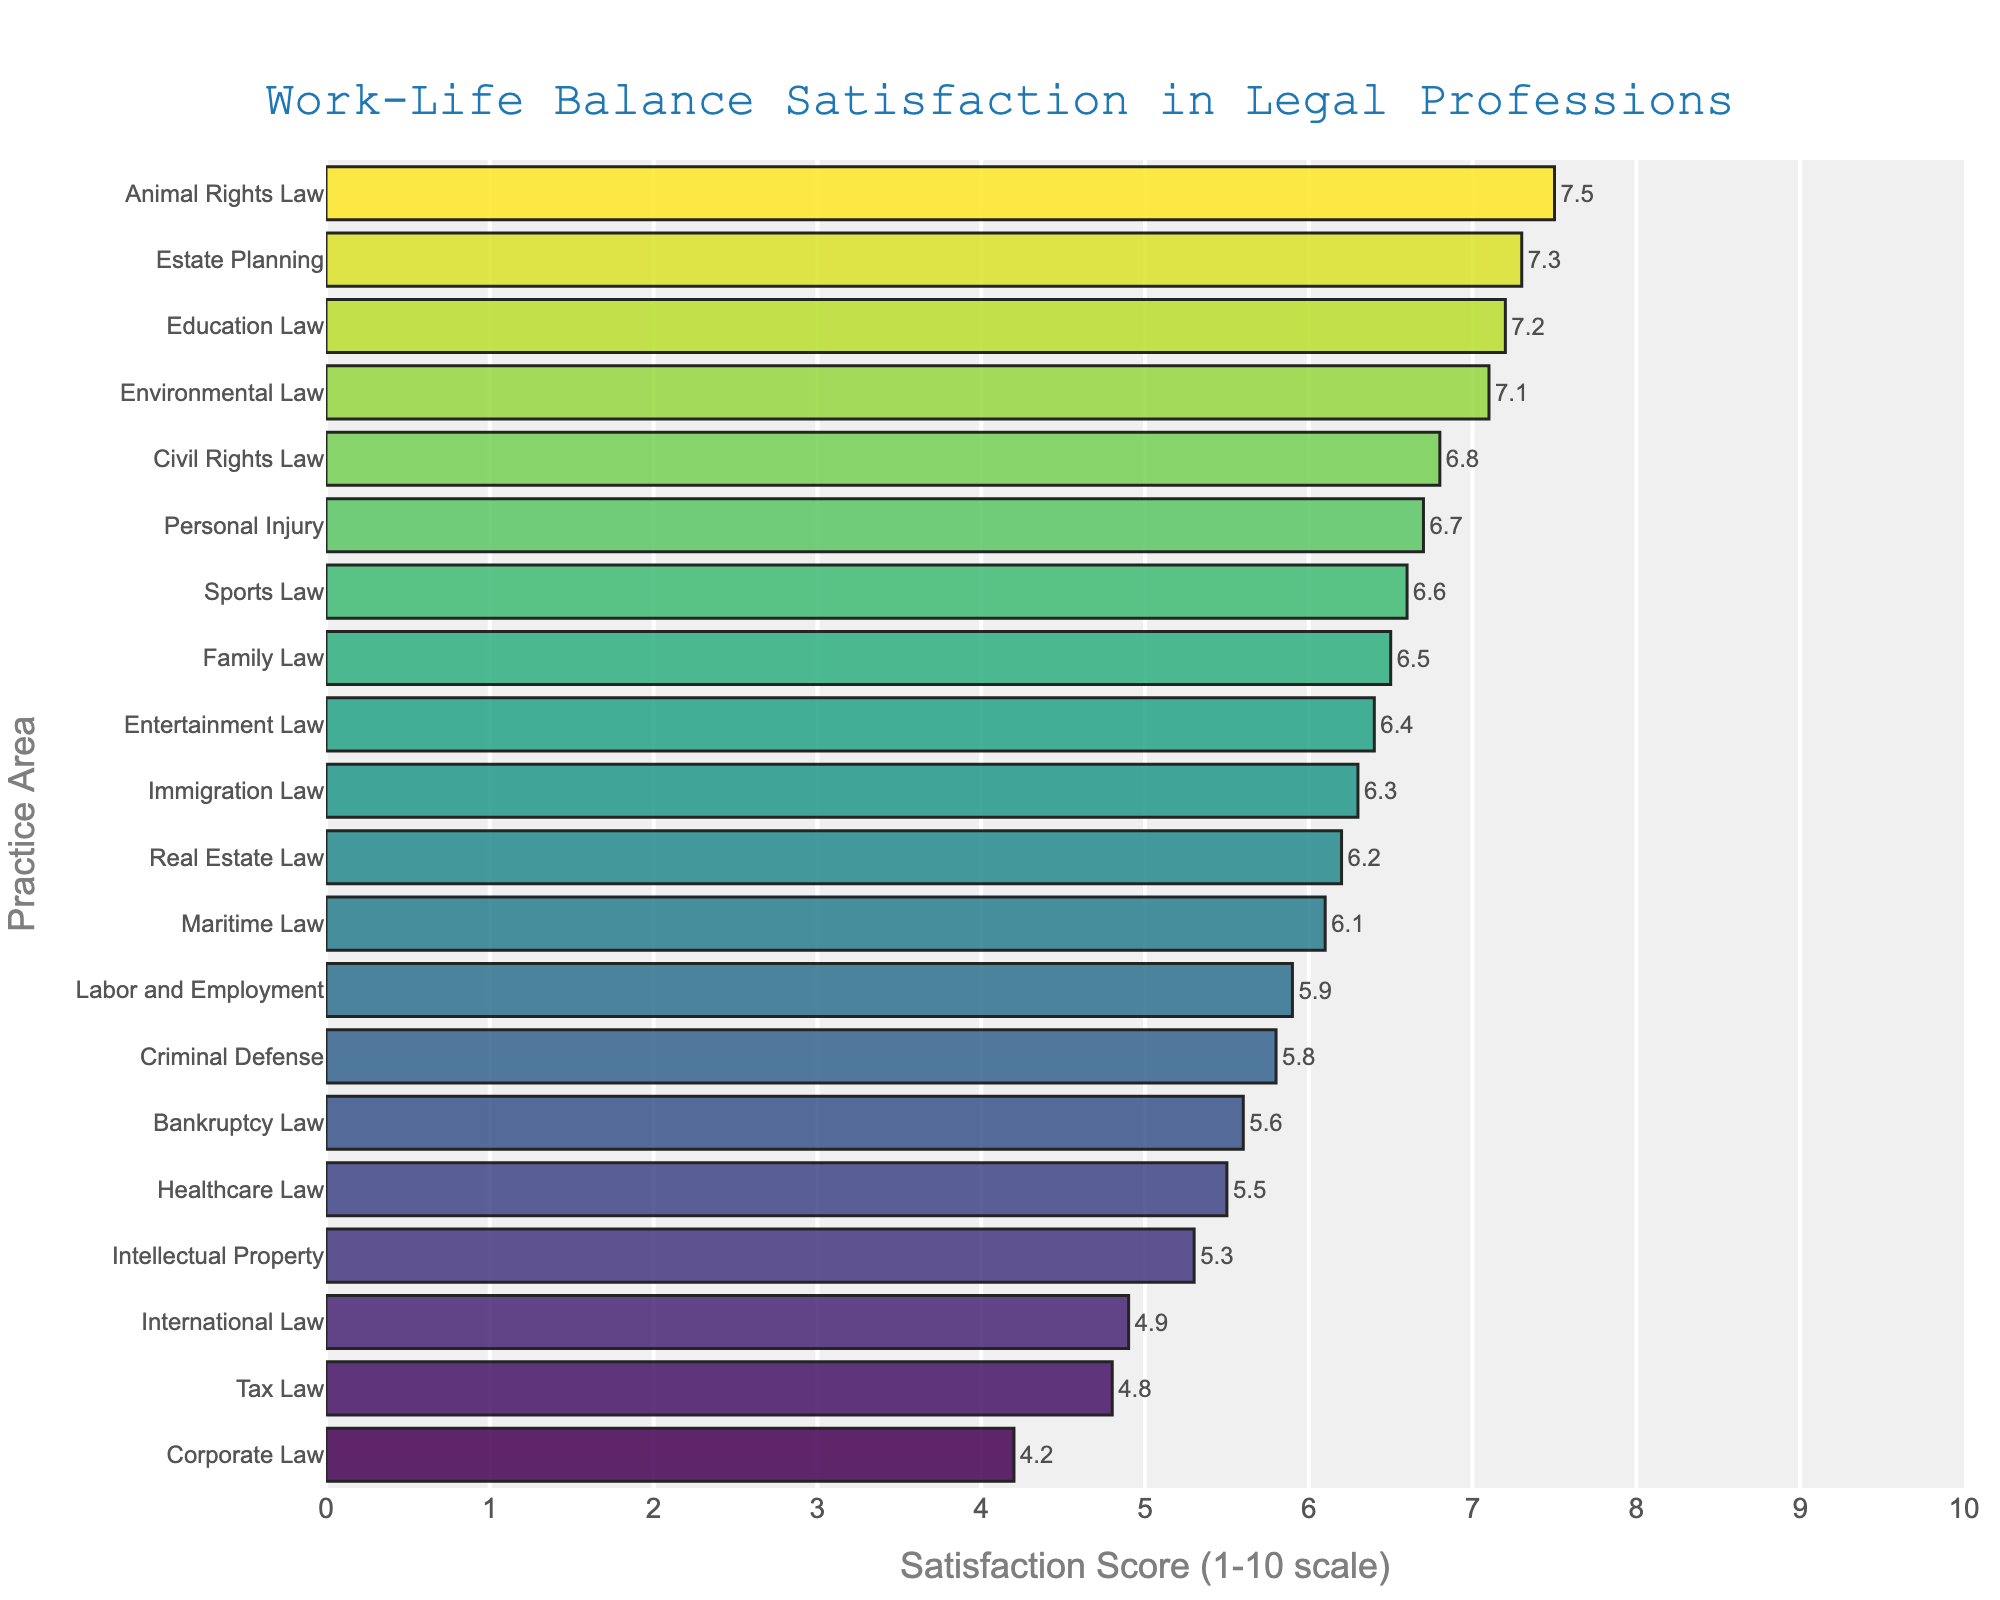How many practice areas have a satisfaction score above 6.0? First, identify the practice areas with scores above 6.0. These are Family Law (6.5), Real Estate Law (6.2), Personal Injury (6.7), Civil Rights Law (6.8), Entertainment Law (6.4), Immigration Law (6.3), Maritime Law (6.1), Sports Law (6.6), Education Law (7.2), Estate Planning (7.3), and Animal Rights Law (7.5). Count them: 11 practice areas have satisfaction scores above 6.0.
Answer: 11 Which practice area has the lowest work-life balance satisfaction score? Look at the leftmost bar in the chart, which represents the lowest score. The practice area corresponding to this bar is Corporate Law with a score of 4.2.
Answer: Corporate Law Is Intellectual Property’s satisfaction score higher or lower than Tax Law’s score? Examine the bars corresponding to Intellectual Property and Tax Law. Intellectual Property has a score of 5.3 and Tax Law has a score of 4.8. Compare these values: 5.3 is higher than 4.8.
Answer: Higher What is the difference in satisfaction score between the highest and lowest practice areas? Find the highest satisfaction score (Animal Rights Law with 7.5) and the lowest satisfaction score (Corporate Law with 4.2). Calculate the difference: 7.5 - 4.2 = 3.3.
Answer: 3.3 Which practice areas have a satisfaction score close to the average satisfaction score of all practice areas? First, calculate the average satisfaction score: (4.2 + 6.5 + 5.8 + 5.3 + 7.1 + 4.8 + 6.2 + 5.9 + 6.7 + 6.3 + 5.6 + 6.8 + 5.5 + 6.4 + 4.9 + 7.3 + 6.1 + 6.6 + 7.2 + 7.5) / 20 = 6.065. Identify practice areas with scores close to this value: Real Estate Law (6.2), Labor and Employment (5.9), Immigration Law (6.3), Entertainment Law (6.4), Maritime Law (6.1).
Answer: Real Estate Law, Labor and Employment, Immigration Law, Entertainment Law, Maritime Law Which practice area has a larger work-life balance satisfaction score: Bankruptcy Law or Healthcare Law? Look for the bars corresponding to Bankruptcy Law and Healthcare Law. Bankruptcy Law has a score of 5.6 and Healthcare Law has a score of 5.5. Compare these values: 5.6 is larger than 5.5.
Answer: Bankruptcy Law What is the median satisfaction score among all practice areas? List all scores in ascending order: 4.2, 4.8, 4.9, 5.3, 5.5, 5.6, 5.8, 5.9, 6.1, 6.2, 6.3, 6.4, 6.5, 6.6, 6.7, 6.8, 7.1, 7.2, 7.3, 7.5. The median is the middle value of this sorted list, which is between the 10th and 11th scores: (6.2 + 6.3) / 2 = 6.25.
Answer: 6.25 Are there more practice areas with satisfaction scores below 5.0 or above 7.0? Count practice areas with scores below 5.0: Corporate Law (4.2), Tax Law (4.8), International Law (4.9), for a total of 3. Count practice areas with scores above 7.0: Environmental Law (7.1), Estate Planning (7.3), Education Law (7.2), Animal Rights Law (7.5), for a total of 4. Compare: 4 is greater than 3.
Answer: Above 7.0 What is the range of work-life balance satisfaction scores for the listed practice areas? Identify the highest score (Animal Rights Law with 7.5) and the lowest score (Corporate Law with 4.2). Calculate the range: 7.5 - 4.2 = 3.3.
Answer: 3.3 